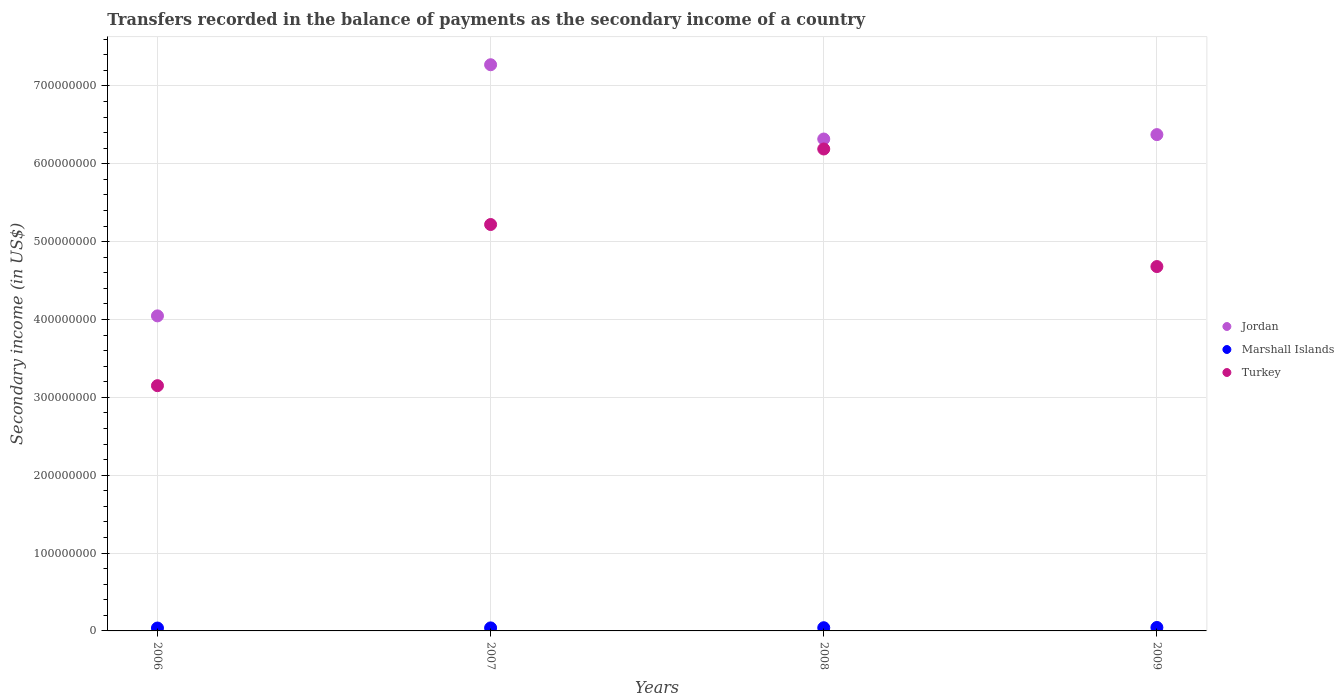How many different coloured dotlines are there?
Provide a succinct answer. 3. What is the secondary income of in Jordan in 2008?
Your answer should be very brief. 6.32e+08. Across all years, what is the maximum secondary income of in Jordan?
Offer a terse response. 7.27e+08. Across all years, what is the minimum secondary income of in Jordan?
Offer a very short reply. 4.05e+08. What is the total secondary income of in Marshall Islands in the graph?
Provide a succinct answer. 1.61e+07. What is the difference between the secondary income of in Jordan in 2008 and that in 2009?
Offer a very short reply. -5.65e+06. What is the difference between the secondary income of in Jordan in 2009 and the secondary income of in Turkey in 2008?
Ensure brevity in your answer.  1.85e+07. What is the average secondary income of in Turkey per year?
Provide a short and direct response. 4.81e+08. In the year 2009, what is the difference between the secondary income of in Marshall Islands and secondary income of in Jordan?
Make the answer very short. -6.33e+08. What is the ratio of the secondary income of in Turkey in 2006 to that in 2009?
Offer a very short reply. 0.67. What is the difference between the highest and the second highest secondary income of in Turkey?
Your answer should be very brief. 9.70e+07. What is the difference between the highest and the lowest secondary income of in Marshall Islands?
Offer a terse response. 7.22e+05. Does the secondary income of in Turkey monotonically increase over the years?
Provide a succinct answer. No. Is the secondary income of in Marshall Islands strictly greater than the secondary income of in Jordan over the years?
Keep it short and to the point. No. How many dotlines are there?
Make the answer very short. 3. How many years are there in the graph?
Provide a succinct answer. 4. What is the difference between two consecutive major ticks on the Y-axis?
Provide a succinct answer. 1.00e+08. Does the graph contain any zero values?
Offer a terse response. No. Where does the legend appear in the graph?
Provide a short and direct response. Center right. What is the title of the graph?
Your response must be concise. Transfers recorded in the balance of payments as the secondary income of a country. Does "Honduras" appear as one of the legend labels in the graph?
Offer a terse response. No. What is the label or title of the Y-axis?
Make the answer very short. Secondary income (in US$). What is the Secondary income (in US$) of Jordan in 2006?
Ensure brevity in your answer.  4.05e+08. What is the Secondary income (in US$) in Marshall Islands in 2006?
Your response must be concise. 3.71e+06. What is the Secondary income (in US$) in Turkey in 2006?
Give a very brief answer. 3.15e+08. What is the Secondary income (in US$) in Jordan in 2007?
Provide a short and direct response. 7.27e+08. What is the Secondary income (in US$) in Marshall Islands in 2007?
Ensure brevity in your answer.  3.88e+06. What is the Secondary income (in US$) of Turkey in 2007?
Offer a terse response. 5.22e+08. What is the Secondary income (in US$) in Jordan in 2008?
Provide a short and direct response. 6.32e+08. What is the Secondary income (in US$) in Marshall Islands in 2008?
Offer a very short reply. 4.11e+06. What is the Secondary income (in US$) of Turkey in 2008?
Keep it short and to the point. 6.19e+08. What is the Secondary income (in US$) of Jordan in 2009?
Offer a very short reply. 6.37e+08. What is the Secondary income (in US$) in Marshall Islands in 2009?
Your response must be concise. 4.43e+06. What is the Secondary income (in US$) in Turkey in 2009?
Your answer should be very brief. 4.68e+08. Across all years, what is the maximum Secondary income (in US$) of Jordan?
Keep it short and to the point. 7.27e+08. Across all years, what is the maximum Secondary income (in US$) in Marshall Islands?
Give a very brief answer. 4.43e+06. Across all years, what is the maximum Secondary income (in US$) in Turkey?
Offer a very short reply. 6.19e+08. Across all years, what is the minimum Secondary income (in US$) in Jordan?
Your response must be concise. 4.05e+08. Across all years, what is the minimum Secondary income (in US$) of Marshall Islands?
Ensure brevity in your answer.  3.71e+06. Across all years, what is the minimum Secondary income (in US$) in Turkey?
Provide a succinct answer. 3.15e+08. What is the total Secondary income (in US$) of Jordan in the graph?
Make the answer very short. 2.40e+09. What is the total Secondary income (in US$) of Marshall Islands in the graph?
Make the answer very short. 1.61e+07. What is the total Secondary income (in US$) in Turkey in the graph?
Your answer should be compact. 1.92e+09. What is the difference between the Secondary income (in US$) of Jordan in 2006 and that in 2007?
Keep it short and to the point. -3.23e+08. What is the difference between the Secondary income (in US$) in Marshall Islands in 2006 and that in 2007?
Offer a very short reply. -1.71e+05. What is the difference between the Secondary income (in US$) of Turkey in 2006 and that in 2007?
Ensure brevity in your answer.  -2.07e+08. What is the difference between the Secondary income (in US$) of Jordan in 2006 and that in 2008?
Give a very brief answer. -2.27e+08. What is the difference between the Secondary income (in US$) in Marshall Islands in 2006 and that in 2008?
Provide a succinct answer. -3.94e+05. What is the difference between the Secondary income (in US$) of Turkey in 2006 and that in 2008?
Offer a terse response. -3.04e+08. What is the difference between the Secondary income (in US$) in Jordan in 2006 and that in 2009?
Your answer should be compact. -2.33e+08. What is the difference between the Secondary income (in US$) in Marshall Islands in 2006 and that in 2009?
Offer a very short reply. -7.22e+05. What is the difference between the Secondary income (in US$) in Turkey in 2006 and that in 2009?
Offer a terse response. -1.53e+08. What is the difference between the Secondary income (in US$) of Jordan in 2007 and that in 2008?
Your response must be concise. 9.54e+07. What is the difference between the Secondary income (in US$) of Marshall Islands in 2007 and that in 2008?
Provide a short and direct response. -2.22e+05. What is the difference between the Secondary income (in US$) in Turkey in 2007 and that in 2008?
Offer a terse response. -9.70e+07. What is the difference between the Secondary income (in US$) of Jordan in 2007 and that in 2009?
Your answer should be very brief. 8.98e+07. What is the difference between the Secondary income (in US$) in Marshall Islands in 2007 and that in 2009?
Ensure brevity in your answer.  -5.51e+05. What is the difference between the Secondary income (in US$) in Turkey in 2007 and that in 2009?
Keep it short and to the point. 5.40e+07. What is the difference between the Secondary income (in US$) of Jordan in 2008 and that in 2009?
Provide a succinct answer. -5.65e+06. What is the difference between the Secondary income (in US$) of Marshall Islands in 2008 and that in 2009?
Keep it short and to the point. -3.28e+05. What is the difference between the Secondary income (in US$) in Turkey in 2008 and that in 2009?
Your answer should be very brief. 1.51e+08. What is the difference between the Secondary income (in US$) of Jordan in 2006 and the Secondary income (in US$) of Marshall Islands in 2007?
Keep it short and to the point. 4.01e+08. What is the difference between the Secondary income (in US$) in Jordan in 2006 and the Secondary income (in US$) in Turkey in 2007?
Offer a very short reply. -1.17e+08. What is the difference between the Secondary income (in US$) in Marshall Islands in 2006 and the Secondary income (in US$) in Turkey in 2007?
Provide a short and direct response. -5.18e+08. What is the difference between the Secondary income (in US$) of Jordan in 2006 and the Secondary income (in US$) of Marshall Islands in 2008?
Offer a terse response. 4.01e+08. What is the difference between the Secondary income (in US$) of Jordan in 2006 and the Secondary income (in US$) of Turkey in 2008?
Your response must be concise. -2.14e+08. What is the difference between the Secondary income (in US$) in Marshall Islands in 2006 and the Secondary income (in US$) in Turkey in 2008?
Offer a terse response. -6.15e+08. What is the difference between the Secondary income (in US$) in Jordan in 2006 and the Secondary income (in US$) in Marshall Islands in 2009?
Keep it short and to the point. 4.00e+08. What is the difference between the Secondary income (in US$) of Jordan in 2006 and the Secondary income (in US$) of Turkey in 2009?
Give a very brief answer. -6.33e+07. What is the difference between the Secondary income (in US$) of Marshall Islands in 2006 and the Secondary income (in US$) of Turkey in 2009?
Give a very brief answer. -4.64e+08. What is the difference between the Secondary income (in US$) of Jordan in 2007 and the Secondary income (in US$) of Marshall Islands in 2008?
Ensure brevity in your answer.  7.23e+08. What is the difference between the Secondary income (in US$) of Jordan in 2007 and the Secondary income (in US$) of Turkey in 2008?
Your answer should be very brief. 1.08e+08. What is the difference between the Secondary income (in US$) in Marshall Islands in 2007 and the Secondary income (in US$) in Turkey in 2008?
Keep it short and to the point. -6.15e+08. What is the difference between the Secondary income (in US$) in Jordan in 2007 and the Secondary income (in US$) in Marshall Islands in 2009?
Your answer should be compact. 7.23e+08. What is the difference between the Secondary income (in US$) of Jordan in 2007 and the Secondary income (in US$) of Turkey in 2009?
Ensure brevity in your answer.  2.59e+08. What is the difference between the Secondary income (in US$) in Marshall Islands in 2007 and the Secondary income (in US$) in Turkey in 2009?
Your response must be concise. -4.64e+08. What is the difference between the Secondary income (in US$) of Jordan in 2008 and the Secondary income (in US$) of Marshall Islands in 2009?
Offer a terse response. 6.27e+08. What is the difference between the Secondary income (in US$) in Jordan in 2008 and the Secondary income (in US$) in Turkey in 2009?
Give a very brief answer. 1.64e+08. What is the difference between the Secondary income (in US$) of Marshall Islands in 2008 and the Secondary income (in US$) of Turkey in 2009?
Make the answer very short. -4.64e+08. What is the average Secondary income (in US$) in Jordan per year?
Offer a terse response. 6.00e+08. What is the average Secondary income (in US$) in Marshall Islands per year?
Provide a succinct answer. 4.03e+06. What is the average Secondary income (in US$) in Turkey per year?
Ensure brevity in your answer.  4.81e+08. In the year 2006, what is the difference between the Secondary income (in US$) in Jordan and Secondary income (in US$) in Marshall Islands?
Make the answer very short. 4.01e+08. In the year 2006, what is the difference between the Secondary income (in US$) in Jordan and Secondary income (in US$) in Turkey?
Ensure brevity in your answer.  8.97e+07. In the year 2006, what is the difference between the Secondary income (in US$) in Marshall Islands and Secondary income (in US$) in Turkey?
Keep it short and to the point. -3.11e+08. In the year 2007, what is the difference between the Secondary income (in US$) in Jordan and Secondary income (in US$) in Marshall Islands?
Your response must be concise. 7.23e+08. In the year 2007, what is the difference between the Secondary income (in US$) of Jordan and Secondary income (in US$) of Turkey?
Offer a terse response. 2.05e+08. In the year 2007, what is the difference between the Secondary income (in US$) of Marshall Islands and Secondary income (in US$) of Turkey?
Provide a succinct answer. -5.18e+08. In the year 2008, what is the difference between the Secondary income (in US$) in Jordan and Secondary income (in US$) in Marshall Islands?
Ensure brevity in your answer.  6.28e+08. In the year 2008, what is the difference between the Secondary income (in US$) of Jordan and Secondary income (in US$) of Turkey?
Give a very brief answer. 1.28e+07. In the year 2008, what is the difference between the Secondary income (in US$) of Marshall Islands and Secondary income (in US$) of Turkey?
Provide a succinct answer. -6.15e+08. In the year 2009, what is the difference between the Secondary income (in US$) in Jordan and Secondary income (in US$) in Marshall Islands?
Your answer should be very brief. 6.33e+08. In the year 2009, what is the difference between the Secondary income (in US$) in Jordan and Secondary income (in US$) in Turkey?
Your answer should be compact. 1.69e+08. In the year 2009, what is the difference between the Secondary income (in US$) of Marshall Islands and Secondary income (in US$) of Turkey?
Your answer should be very brief. -4.64e+08. What is the ratio of the Secondary income (in US$) of Jordan in 2006 to that in 2007?
Keep it short and to the point. 0.56. What is the ratio of the Secondary income (in US$) in Marshall Islands in 2006 to that in 2007?
Your response must be concise. 0.96. What is the ratio of the Secondary income (in US$) in Turkey in 2006 to that in 2007?
Provide a short and direct response. 0.6. What is the ratio of the Secondary income (in US$) of Jordan in 2006 to that in 2008?
Make the answer very short. 0.64. What is the ratio of the Secondary income (in US$) in Marshall Islands in 2006 to that in 2008?
Offer a very short reply. 0.9. What is the ratio of the Secondary income (in US$) in Turkey in 2006 to that in 2008?
Provide a short and direct response. 0.51. What is the ratio of the Secondary income (in US$) in Jordan in 2006 to that in 2009?
Provide a short and direct response. 0.63. What is the ratio of the Secondary income (in US$) in Marshall Islands in 2006 to that in 2009?
Offer a terse response. 0.84. What is the ratio of the Secondary income (in US$) in Turkey in 2006 to that in 2009?
Your answer should be compact. 0.67. What is the ratio of the Secondary income (in US$) in Jordan in 2007 to that in 2008?
Offer a terse response. 1.15. What is the ratio of the Secondary income (in US$) of Marshall Islands in 2007 to that in 2008?
Keep it short and to the point. 0.95. What is the ratio of the Secondary income (in US$) in Turkey in 2007 to that in 2008?
Give a very brief answer. 0.84. What is the ratio of the Secondary income (in US$) in Jordan in 2007 to that in 2009?
Your response must be concise. 1.14. What is the ratio of the Secondary income (in US$) in Marshall Islands in 2007 to that in 2009?
Give a very brief answer. 0.88. What is the ratio of the Secondary income (in US$) of Turkey in 2007 to that in 2009?
Provide a succinct answer. 1.12. What is the ratio of the Secondary income (in US$) in Marshall Islands in 2008 to that in 2009?
Give a very brief answer. 0.93. What is the ratio of the Secondary income (in US$) of Turkey in 2008 to that in 2009?
Your answer should be very brief. 1.32. What is the difference between the highest and the second highest Secondary income (in US$) in Jordan?
Ensure brevity in your answer.  8.98e+07. What is the difference between the highest and the second highest Secondary income (in US$) of Marshall Islands?
Your response must be concise. 3.28e+05. What is the difference between the highest and the second highest Secondary income (in US$) in Turkey?
Your answer should be compact. 9.70e+07. What is the difference between the highest and the lowest Secondary income (in US$) in Jordan?
Your answer should be compact. 3.23e+08. What is the difference between the highest and the lowest Secondary income (in US$) of Marshall Islands?
Your answer should be compact. 7.22e+05. What is the difference between the highest and the lowest Secondary income (in US$) in Turkey?
Offer a very short reply. 3.04e+08. 